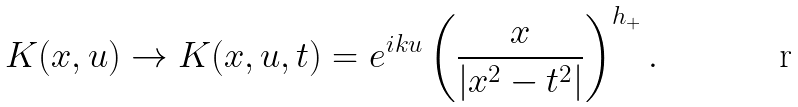<formula> <loc_0><loc_0><loc_500><loc_500>K ( x , u ) \to K ( x , u , t ) = e ^ { i k u } \left ( \frac { x } { | x ^ { 2 } - t ^ { 2 } | } \right ) ^ { h _ { + } } .</formula> 